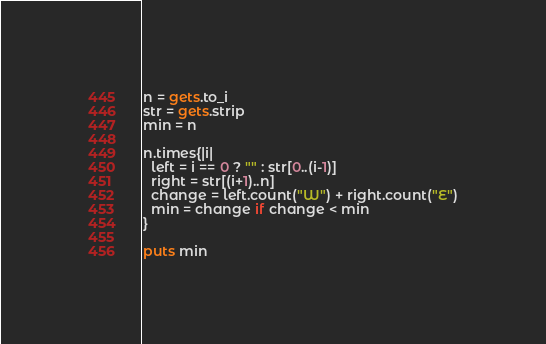Convert code to text. <code><loc_0><loc_0><loc_500><loc_500><_Ruby_>n = gets.to_i
str = gets.strip
min = n

n.times{|i|
  left = i == 0 ? "" : str[0..(i-1)]
  right = str[(i+1)..n]
  change = left.count("W") + right.count("E")
  min = change if change < min
}

puts min</code> 